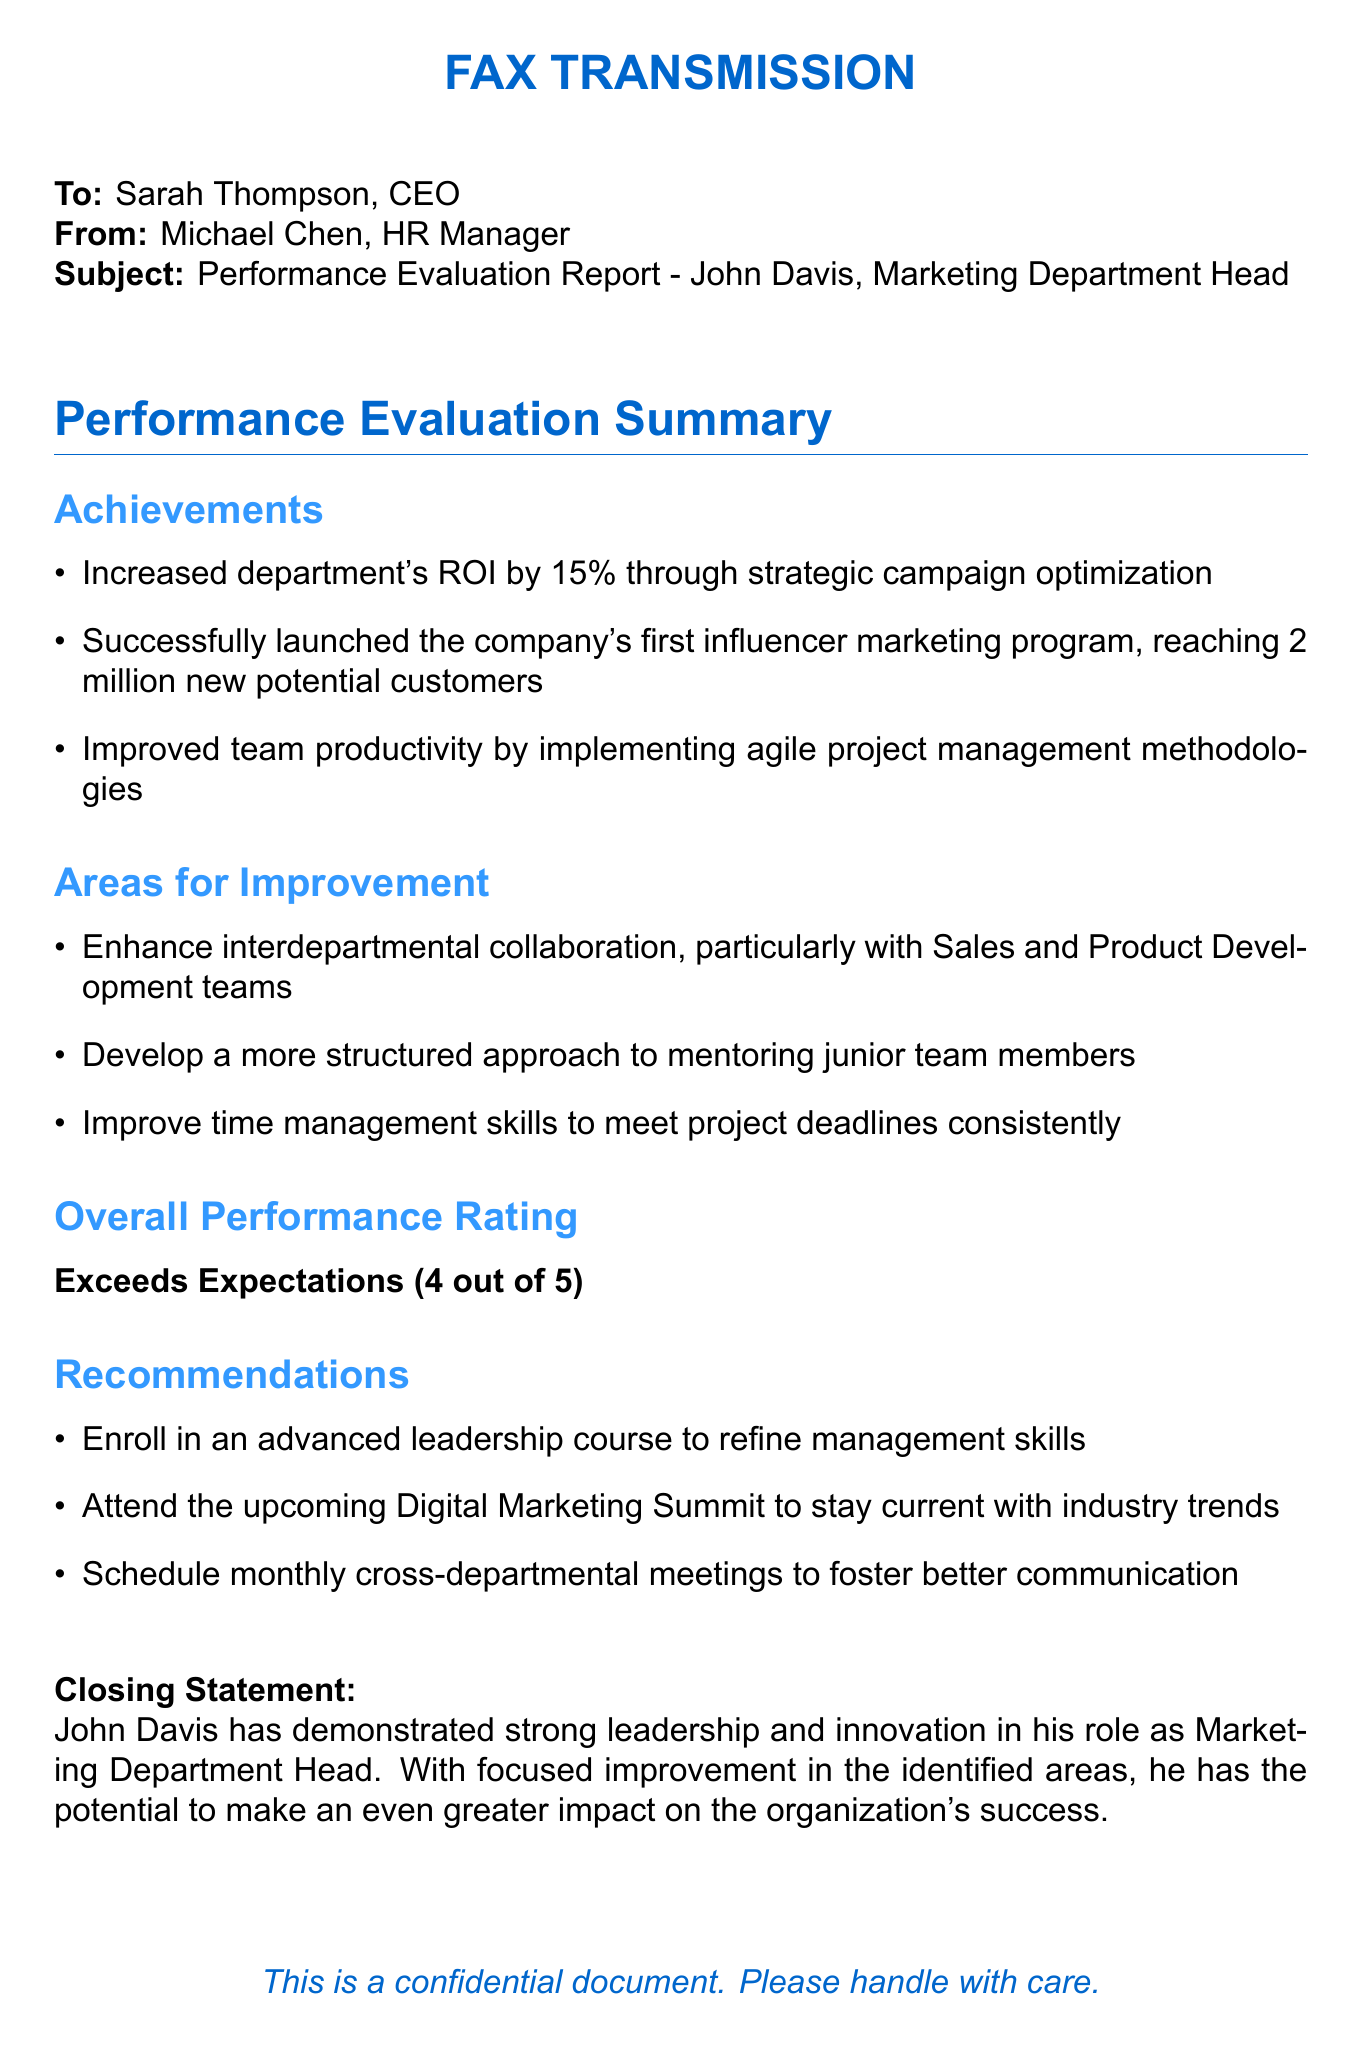What is the subject of the fax? The subject explicitly stated in the document is the performance evaluation report for John Davis.
Answer: Performance Evaluation Report - John Davis, Marketing Department Head Who is the sender of the fax? The sender named in the document is Michael Chen.
Answer: Michael Chen What is the overall performance rating given to John Davis? The overall performance rating is provided in a clear format, indicating the level achieved by John Davis.
Answer: Exceeds Expectations (4 out of 5) What percentage increase in ROI was achieved by the department? The document specifies the exact percentage increase in ROI resulting from the department's strategic efforts.
Answer: 15% What is one area for improvement mentioned in the report? The report highlights specific areas that require attention, one of which can be identified as enhancing collaboration.
Answer: Enhance interdepartmental collaboration What does the report recommend for John Davis? The recommendations section lists specific actions for John Davis to undertake, one being an enrollment in a course.
Answer: Enroll in an advanced leadership course How many new potential customers were reached through the influencer marketing program? The document quantifies the outcome of the marketing initiative by providing a specific number.
Answer: 2 million What methodology was implemented to improve team productivity? The document cites a specific approach used to enhance team efficiency, which can be derived directly from the text.
Answer: Agile project management methodologies What is the name of the person receiving the fax? The name of the recipient is clearly indicated in the opening lines of the document.
Answer: Sarah Thompson 